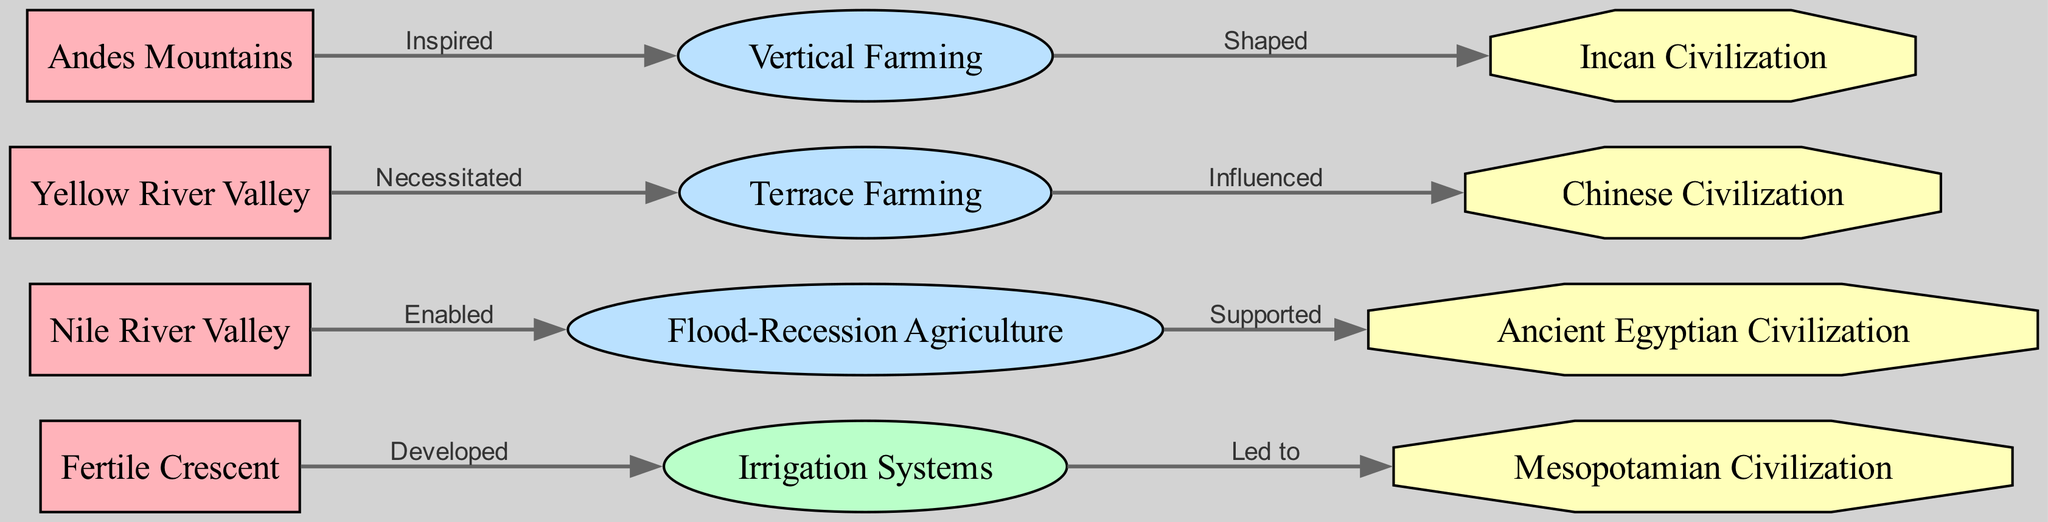What region is associated with irrigation systems? The diagram shows an edge from "Fertile Crescent" to "Irrigation Systems", indicating that irrigation systems were developed in the Fertile Crescent region.
Answer: Fertile Crescent Which society is influenced by terrace farming? The diagram has an edge leading from "Terrace Farming" to "Chinese Civilization", signifying that terrace farming influenced the development of Chinese civilization.
Answer: Chinese Civilization How many regions are shown in the diagram? By counting the "Region" nodes in the diagram, we find there are four regions: Fertile Crescent, Nile River Valley, Yellow River Valley, and Andes Mountains.
Answer: 4 What agricultural practice is supported by flood-recession agriculture? The diagram connects "Flood-Recession Agriculture" to "Ancient Egyptian Civilization" through an edge labeled "Supported", indicating that this agricultural practice supported the society.
Answer: Ancient Egyptian Civilization What technology developed in the Fertile Crescent led to the Mesopotamian civilization? The diagram depicts that "Irrigation Systems" developed in the "Fertile Crescent" and led to the emergence of "Mesopotamian Civilization".
Answer: Irrigation Systems What farming technique is inspired by the Andes Mountains? The flowchart shows that "Vertical Farming" is inspired by the "Andes Mountains", as indicated by the edge labeled "Inspired".
Answer: Vertical Farming Which agricultural practice was necessitated by the Yellow River Valley? The diagram indicates that the Yellow River Valley necessitated the practice of "Terrace Farming", as shown by the edge connecting the two.
Answer: Terrace Farming What connection exists between the Andes Mountains and the Incan civilization? The flowchart demonstrates that "Vertical Farming" shaped the development of the "Incan Civilization", establishing a direct relationship between the two.
Answer: Vertical Farming Which two societies are connected through a common agricultural practice in the diagram? Both "Ancient Egyptian Civilization" and "Chinese Civilization" are connected to an agricultural practice, respectively supported by "Flood-Recession Agriculture" and influenced by "Terrace Farming".
Answer: Ancient Egyptian Civilization and Chinese Civilization 